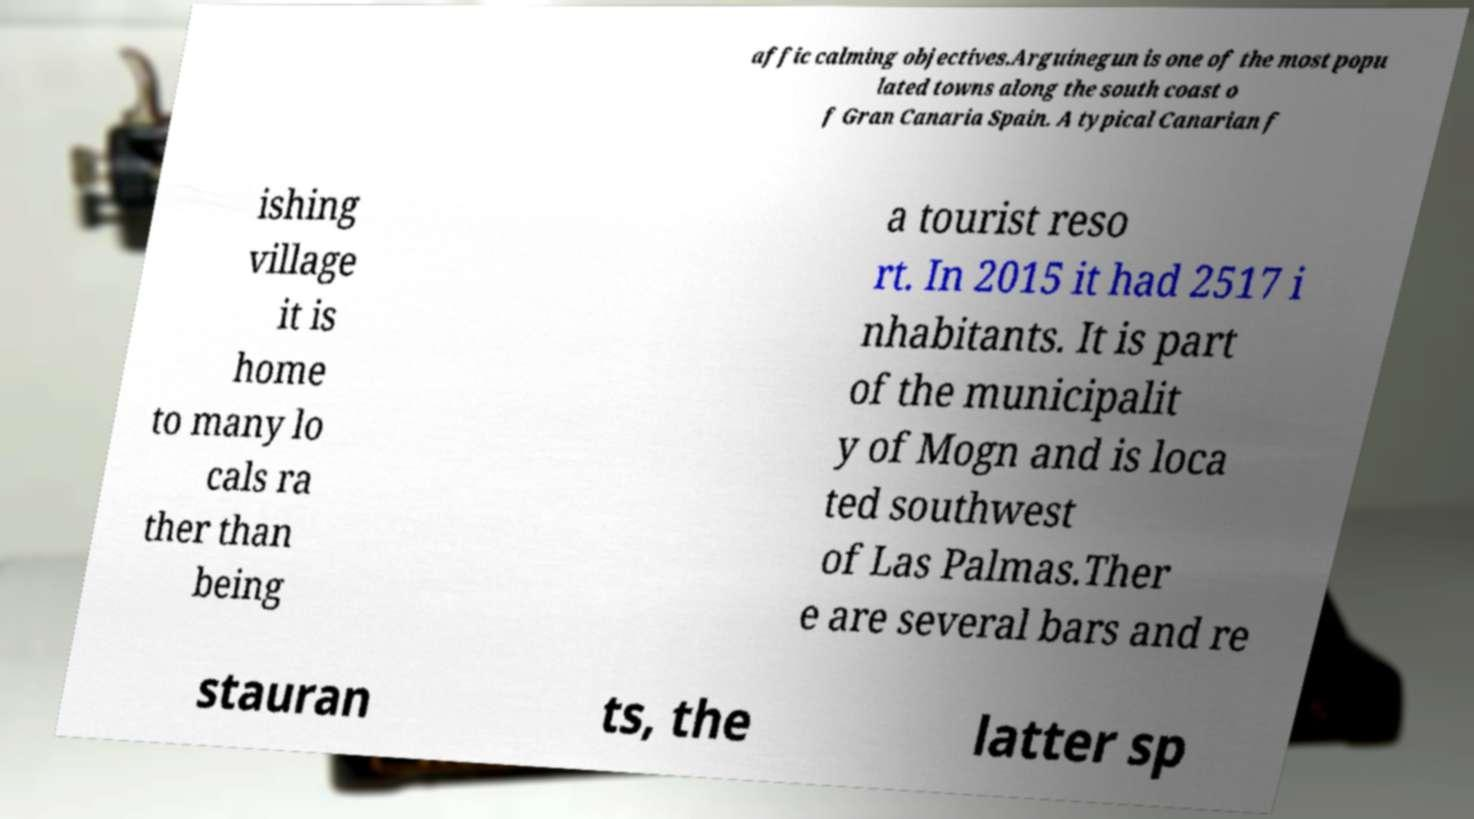Could you assist in decoding the text presented in this image and type it out clearly? affic calming objectives.Arguinegun is one of the most popu lated towns along the south coast o f Gran Canaria Spain. A typical Canarian f ishing village it is home to many lo cals ra ther than being a tourist reso rt. In 2015 it had 2517 i nhabitants. It is part of the municipalit y of Mogn and is loca ted southwest of Las Palmas.Ther e are several bars and re stauran ts, the latter sp 